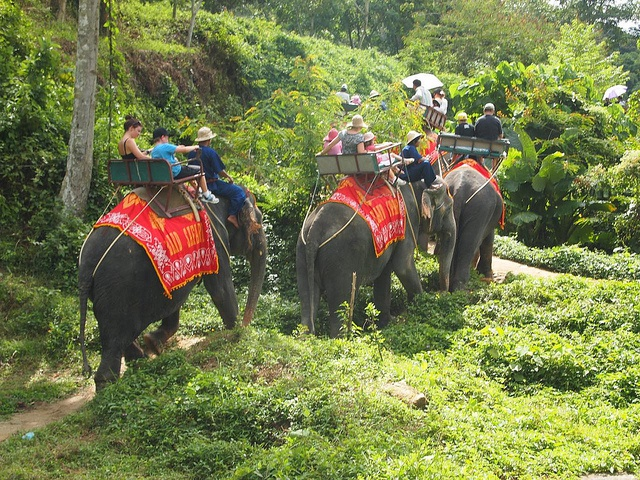Describe the objects in this image and their specific colors. I can see elephant in khaki, black, gray, darkgreen, and red tones, elephant in khaki, gray, black, and darkgreen tones, elephant in khaki, gray, black, darkgreen, and darkgray tones, bench in khaki, black, teal, maroon, and gray tones, and people in khaki, navy, black, and gray tones in this image. 